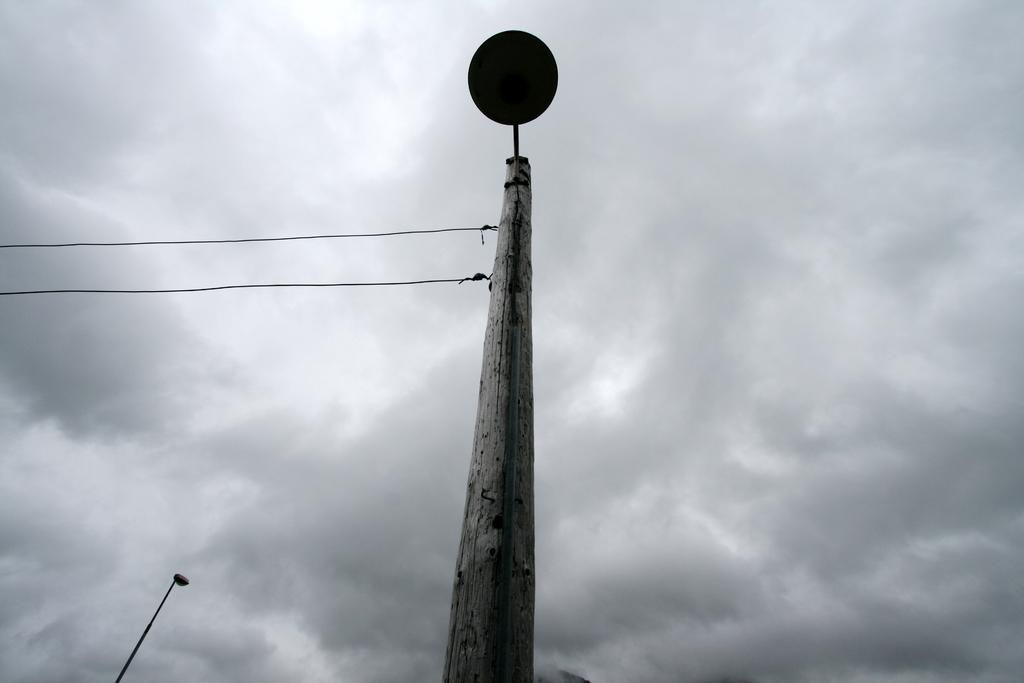What is the main object in the image? There is a pole in the image. What else can be seen in the image besides the pole? There are wires in the image. What is visible in the background of the image? The sky is visible in the background of the image. Can you describe the sky in the image? Clouds are present in the sky. What type of sheet is being used to crush the pole in the image? There is no sheet or crushing action present in the image; it only features a pole and wires. 